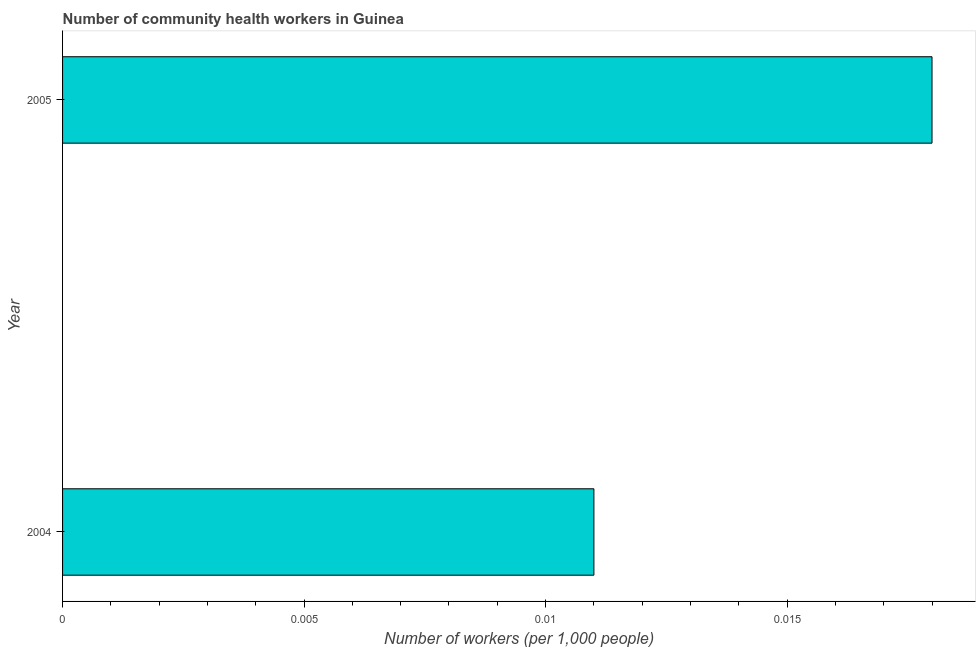Does the graph contain any zero values?
Keep it short and to the point. No. Does the graph contain grids?
Ensure brevity in your answer.  No. What is the title of the graph?
Offer a terse response. Number of community health workers in Guinea. What is the label or title of the X-axis?
Keep it short and to the point. Number of workers (per 1,0 people). What is the label or title of the Y-axis?
Ensure brevity in your answer.  Year. What is the number of community health workers in 2004?
Provide a short and direct response. 0.01. Across all years, what is the maximum number of community health workers?
Your answer should be very brief. 0.02. Across all years, what is the minimum number of community health workers?
Your answer should be compact. 0.01. In which year was the number of community health workers minimum?
Make the answer very short. 2004. What is the sum of the number of community health workers?
Provide a succinct answer. 0.03. What is the difference between the number of community health workers in 2004 and 2005?
Your answer should be compact. -0.01. What is the average number of community health workers per year?
Your answer should be compact. 0.01. What is the median number of community health workers?
Make the answer very short. 0.01. In how many years, is the number of community health workers greater than 0.013 ?
Provide a short and direct response. 1. Do a majority of the years between 2004 and 2005 (inclusive) have number of community health workers greater than 0.013 ?
Offer a very short reply. No. What is the ratio of the number of community health workers in 2004 to that in 2005?
Your answer should be compact. 0.61. In how many years, is the number of community health workers greater than the average number of community health workers taken over all years?
Provide a succinct answer. 1. How many bars are there?
Your response must be concise. 2. Are all the bars in the graph horizontal?
Make the answer very short. Yes. What is the difference between two consecutive major ticks on the X-axis?
Your answer should be very brief. 0.01. Are the values on the major ticks of X-axis written in scientific E-notation?
Your answer should be very brief. No. What is the Number of workers (per 1,000 people) in 2004?
Ensure brevity in your answer.  0.01. What is the Number of workers (per 1,000 people) of 2005?
Keep it short and to the point. 0.02. What is the difference between the Number of workers (per 1,000 people) in 2004 and 2005?
Your answer should be compact. -0.01. What is the ratio of the Number of workers (per 1,000 people) in 2004 to that in 2005?
Provide a short and direct response. 0.61. 